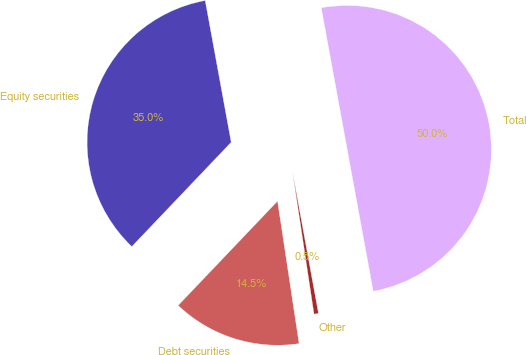<chart> <loc_0><loc_0><loc_500><loc_500><pie_chart><fcel>Equity securities<fcel>Debt securities<fcel>Other<fcel>Total<nl><fcel>35.0%<fcel>14.5%<fcel>0.5%<fcel>50.0%<nl></chart> 